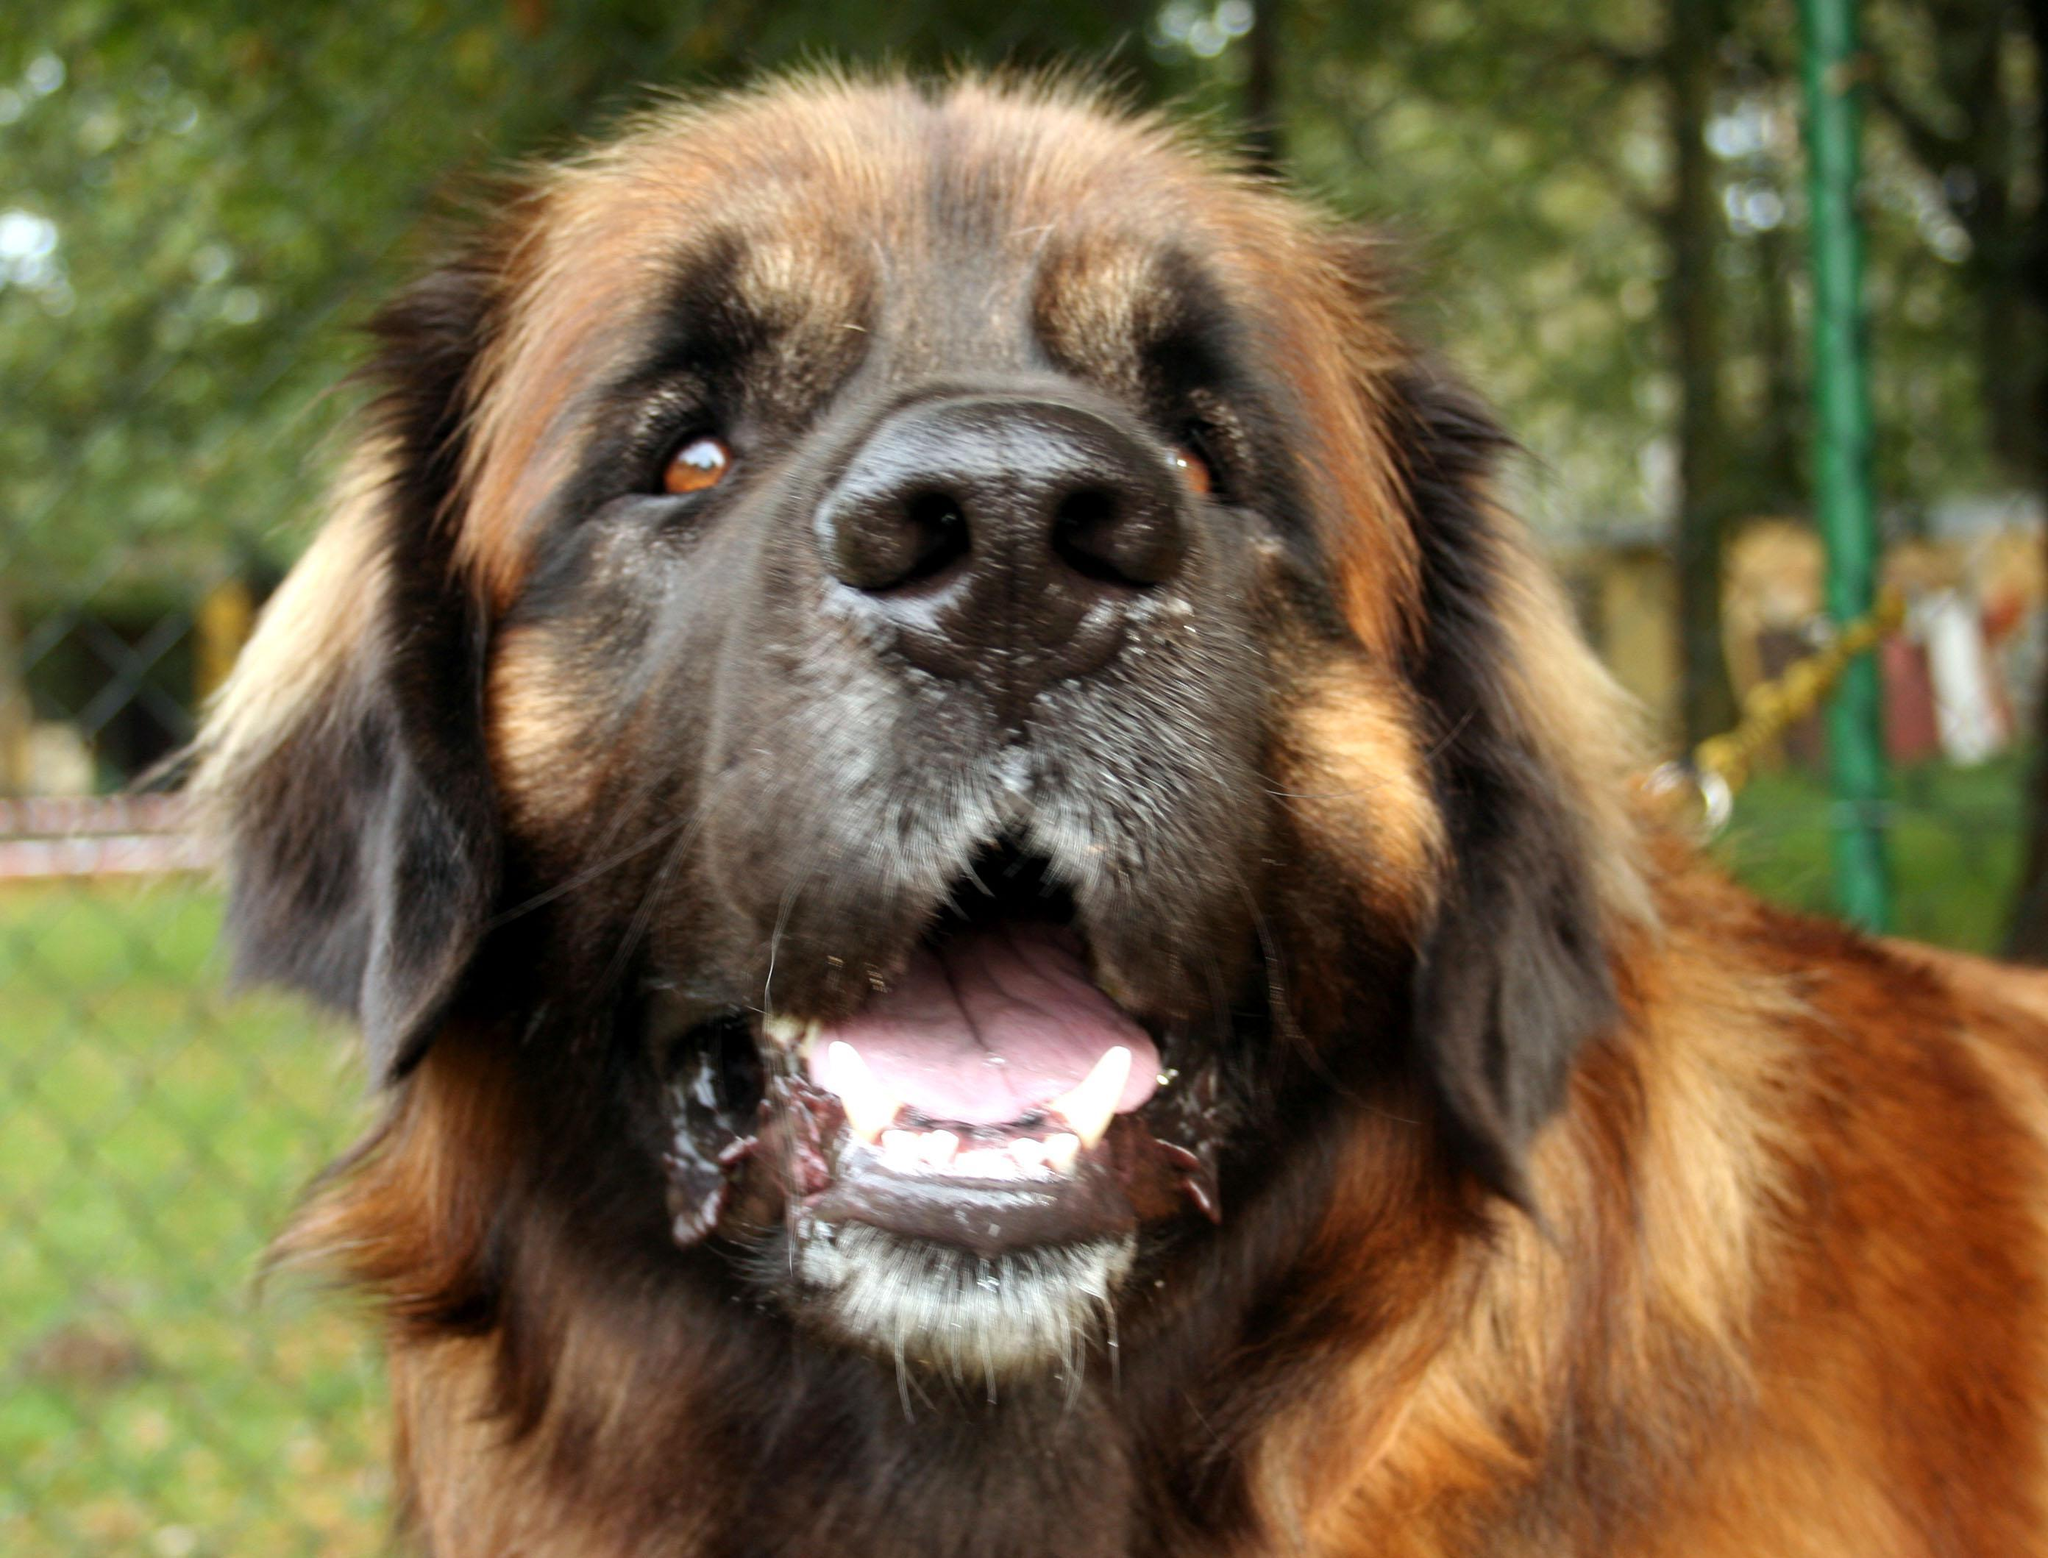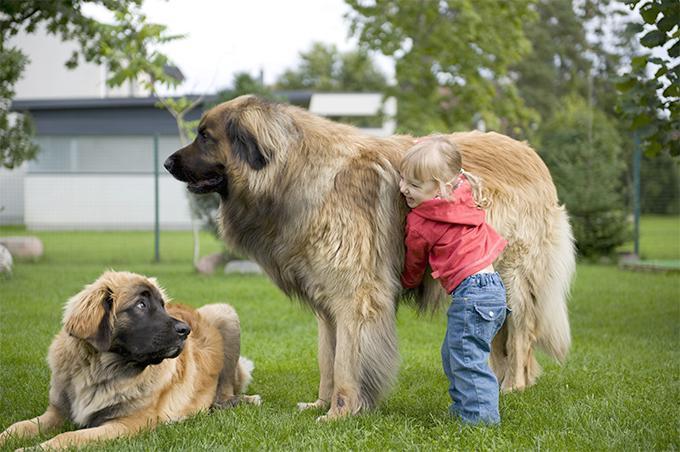The first image is the image on the left, the second image is the image on the right. For the images displayed, is the sentence "A person is standing by a large dog in one image." factually correct? Answer yes or no. Yes. 